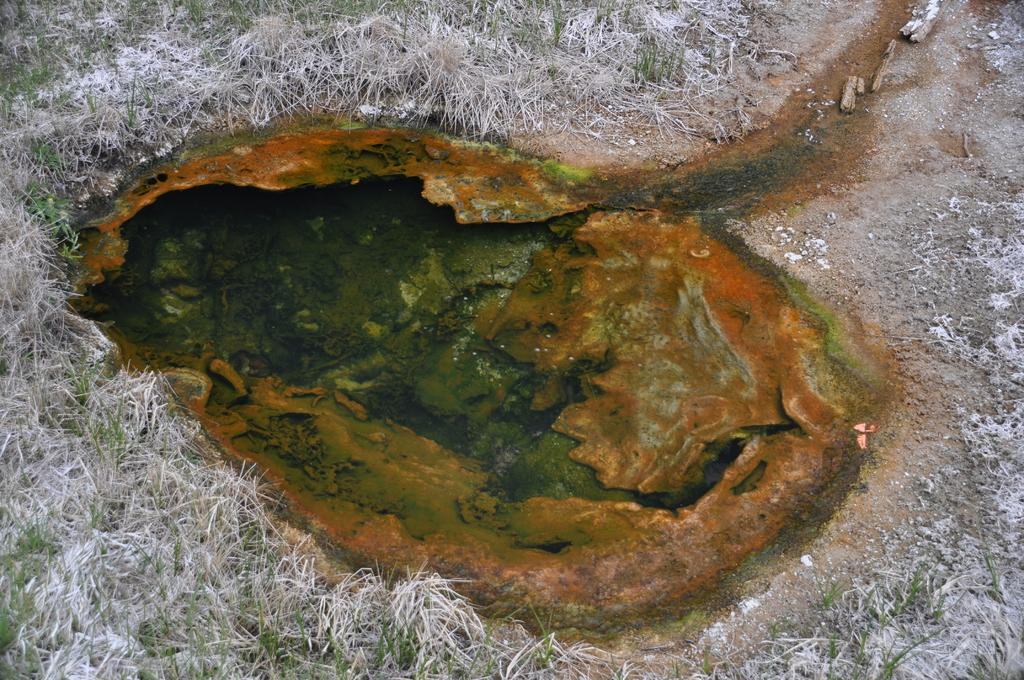What is the main feature in the center of the image? There is a small water hole in the center of the image. What can be observed in the water hole? The water hole has green algae. What type of vegetation is visible in the background of the image? There is grass visible in the background of the image. What is the name of the daughter who is taking a bath in the image? There is no daughter or bath present in the image; it features a small water hole with green algae and grass in the background. 